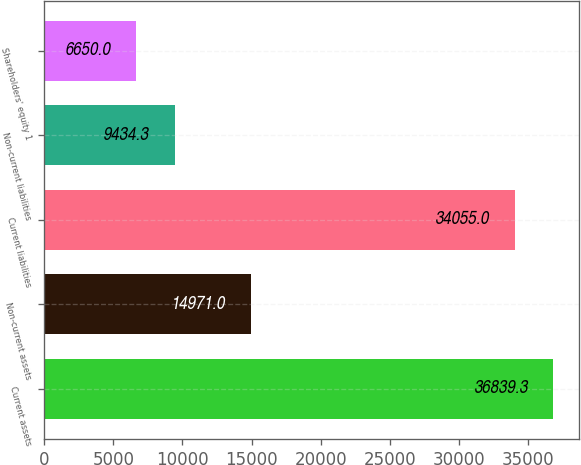Convert chart to OTSL. <chart><loc_0><loc_0><loc_500><loc_500><bar_chart><fcel>Current assets<fcel>Non-current assets<fcel>Current liabilities<fcel>Non-current liabilities<fcel>Shareholders' equity 1<nl><fcel>36839.3<fcel>14971<fcel>34055<fcel>9434.3<fcel>6650<nl></chart> 